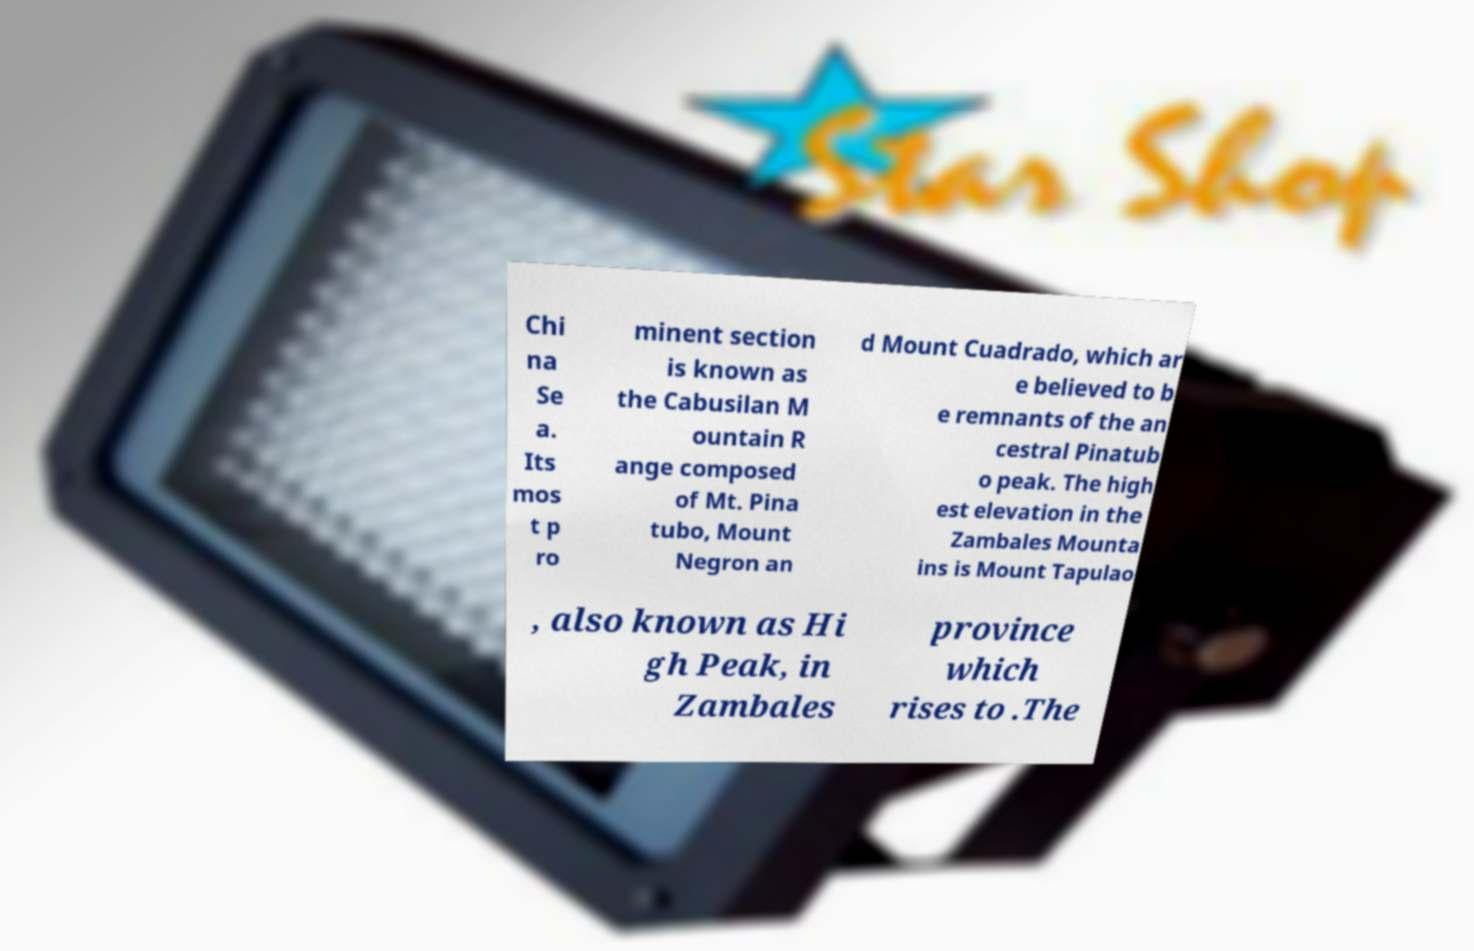Could you assist in decoding the text presented in this image and type it out clearly? Chi na Se a. Its mos t p ro minent section is known as the Cabusilan M ountain R ange composed of Mt. Pina tubo, Mount Negron an d Mount Cuadrado, which ar e believed to b e remnants of the an cestral Pinatub o peak. The high est elevation in the Zambales Mounta ins is Mount Tapulao , also known as Hi gh Peak, in Zambales province which rises to .The 